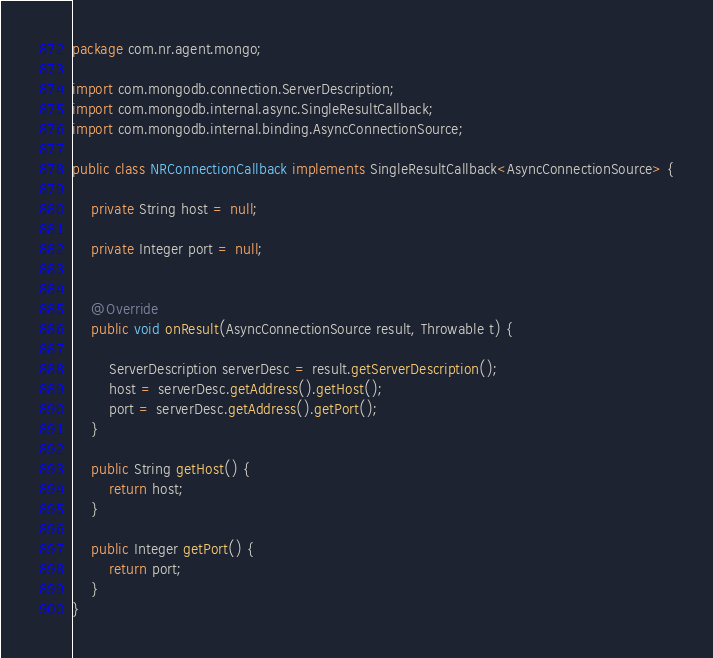Convert code to text. <code><loc_0><loc_0><loc_500><loc_500><_Java_>package com.nr.agent.mongo;

import com.mongodb.connection.ServerDescription;
import com.mongodb.internal.async.SingleResultCallback;
import com.mongodb.internal.binding.AsyncConnectionSource;

public class NRConnectionCallback implements SingleResultCallback<AsyncConnectionSource> {
	
	private String host = null;
	
	private Integer port = null;
	

	@Override
	public void onResult(AsyncConnectionSource result, Throwable t) {

		ServerDescription serverDesc = result.getServerDescription();
		host = serverDesc.getAddress().getHost();
		port = serverDesc.getAddress().getPort();
	}

	public String getHost() {
		return host;
	}
	
	public Integer getPort() {
		return port;
	}
}
</code> 